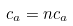Convert formula to latex. <formula><loc_0><loc_0><loc_500><loc_500>c _ { a } = n c _ { a }</formula> 